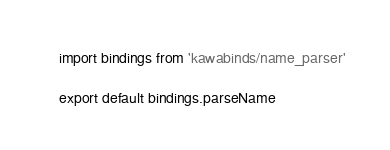Convert code to text. <code><loc_0><loc_0><loc_500><loc_500><_JavaScript_>import bindings from 'kawabinds/name_parser'

export default bindings.parseName
</code> 